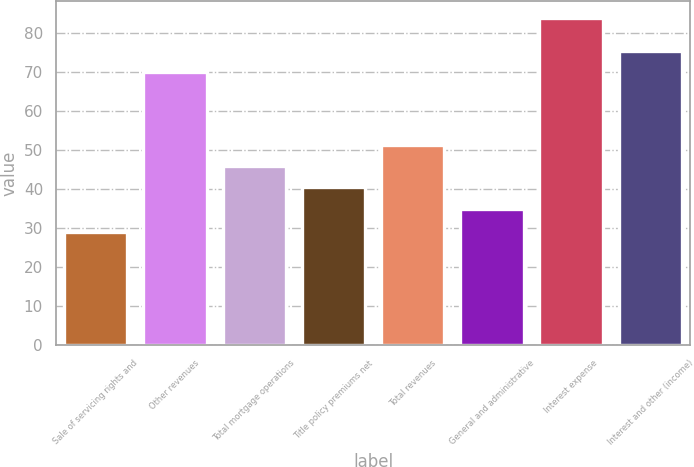Convert chart. <chart><loc_0><loc_0><loc_500><loc_500><bar_chart><fcel>Sale of servicing rights and<fcel>Other revenues<fcel>Total mortgage operations<fcel>Title policy premiums net<fcel>Total revenues<fcel>General and administrative<fcel>Interest expense<fcel>Interest and other (income)<nl><fcel>29<fcel>70<fcel>46<fcel>40.5<fcel>51.5<fcel>35<fcel>84<fcel>75.5<nl></chart> 